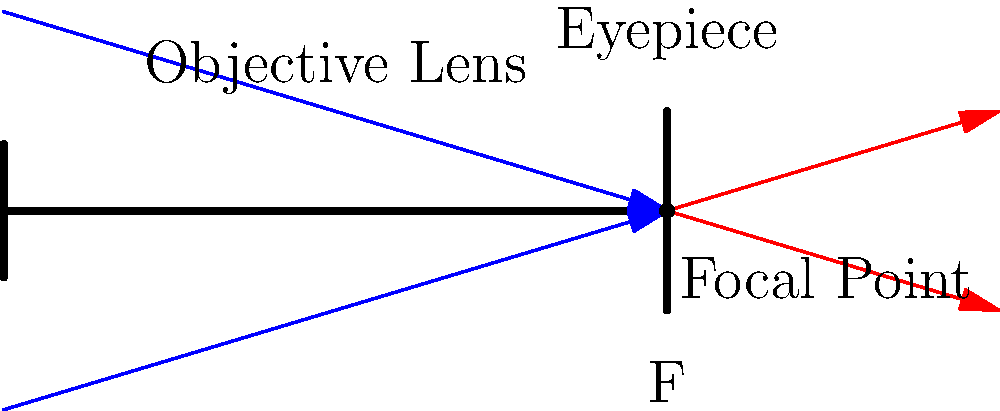As a waiter passionate about astronomy, you often discuss celestial objects with your customers. Explain how a simple refracting telescope, like the one shown in the diagram, magnifies distant objects such as stars or planets. What is the primary factor that determines the magnification power of this telescope? To understand how a simple refracting telescope magnifies celestial objects, let's break it down step-by-step:

1. Light collection: The objective lens (the larger lens at the front of the telescope) collects light from distant objects.

2. Focal point: The collected light is focused to a point called the focal point (F in the diagram). This creates a small, inverted image of the distant object.

3. Eyepiece function: The eyepiece (the smaller lens at the back of the telescope) acts as a magnifying glass for this small image.

4. Magnification: The magnification of the telescope is determined by the ratio of the focal lengths of the objective lens and the eyepiece. It can be calculated using the formula:

   $$ \text{Magnification} = \frac{\text{Focal length of objective lens}}{\text{Focal length of eyepiece}} $$

5. Image formation: The eyepiece creates a virtual, enlarged image of the small real image formed by the objective lens.

The primary factor determining the magnification power of this telescope is the ratio of the focal lengths of the objective lens and the eyepiece. A longer focal length for the objective lens or a shorter focal length for the eyepiece will result in higher magnification.
Answer: Ratio of objective lens focal length to eyepiece focal length 